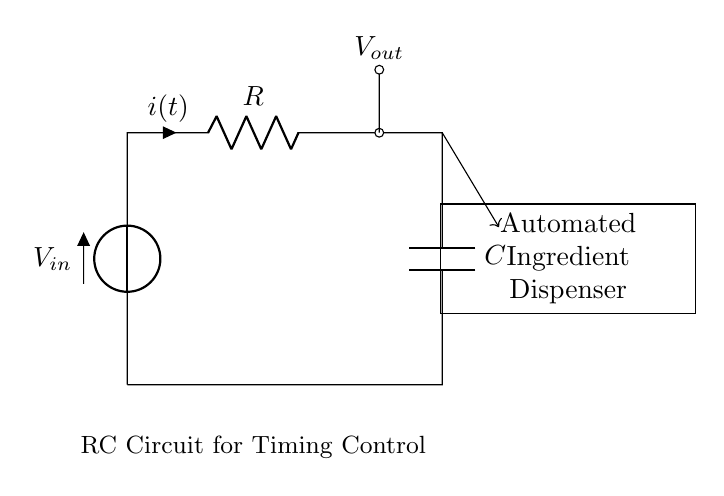What components does this circuit have? The circuit contains a voltage source, a resistor, and a capacitor. Each component is labeled appropriately in the diagram.
Answer: voltage source, resistor, capacitor What is the role of the resistor in this circuit? The resistor controls the current flow through the circuit, determining the charging and discharging time of the capacitor, thereby influencing timing control.
Answer: current control What is the output voltage referred to in this circuit? The output voltage is measured across the capacitor in the circuit. It indicates the voltage level that will control the timing function of the automated ingredient dispenser.
Answer: Vout How does the capacitor affect the timing control? The capacitor stores electrical energy and its charge and discharge times influence how quickly the circuit can respond. The timing is determined by the resistor-capacitor time constant, which affects the dispensing mechanism's timing.
Answer: timing control What would happen if the resistor value is increased? Increasing the resistor value would result in a longer time constant, meaning the capacitor would take more time to charge and discharge, thus delaying the timing control for dispensing.
Answer: longer delay 